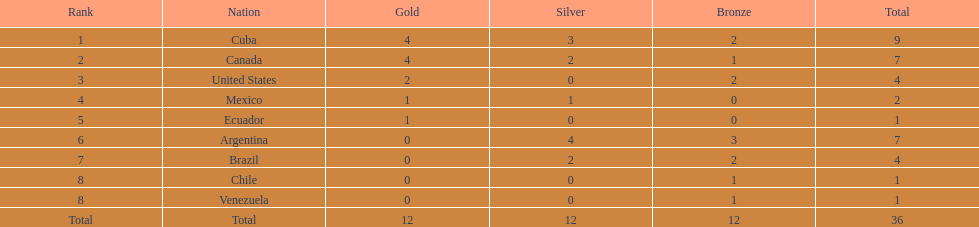Which nation achieved gold but didn't accomplish silver? United States. 